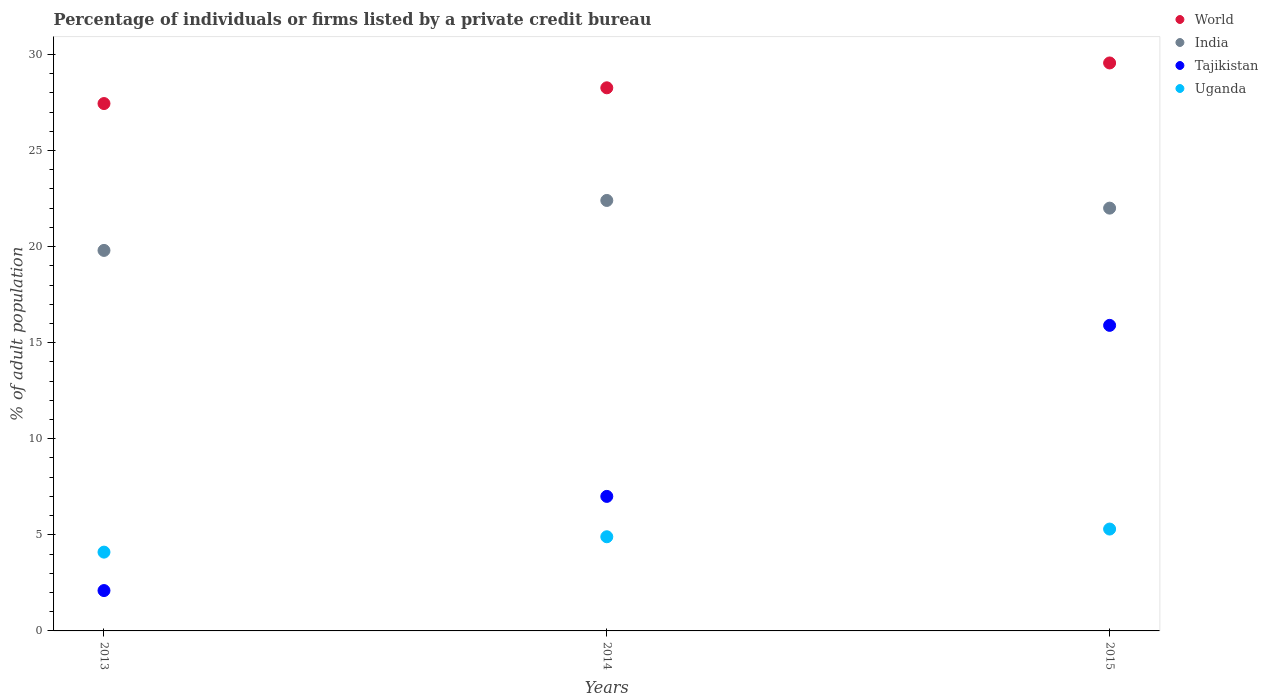Is the number of dotlines equal to the number of legend labels?
Provide a short and direct response. Yes. What is the percentage of population listed by a private credit bureau in World in 2013?
Provide a short and direct response. 27.44. Across all years, what is the minimum percentage of population listed by a private credit bureau in World?
Give a very brief answer. 27.44. In which year was the percentage of population listed by a private credit bureau in Uganda maximum?
Offer a very short reply. 2015. What is the total percentage of population listed by a private credit bureau in India in the graph?
Ensure brevity in your answer.  64.2. What is the difference between the percentage of population listed by a private credit bureau in World in 2013 and that in 2015?
Provide a succinct answer. -2.11. What is the average percentage of population listed by a private credit bureau in World per year?
Make the answer very short. 28.42. In the year 2013, what is the difference between the percentage of population listed by a private credit bureau in India and percentage of population listed by a private credit bureau in Uganda?
Ensure brevity in your answer.  15.7. In how many years, is the percentage of population listed by a private credit bureau in World greater than 7 %?
Give a very brief answer. 3. Is the percentage of population listed by a private credit bureau in Tajikistan in 2014 less than that in 2015?
Ensure brevity in your answer.  Yes. What is the difference between the highest and the second highest percentage of population listed by a private credit bureau in India?
Your answer should be compact. 0.4. What is the difference between the highest and the lowest percentage of population listed by a private credit bureau in Uganda?
Give a very brief answer. 1.2. Is it the case that in every year, the sum of the percentage of population listed by a private credit bureau in India and percentage of population listed by a private credit bureau in Tajikistan  is greater than the percentage of population listed by a private credit bureau in Uganda?
Give a very brief answer. Yes. What is the difference between two consecutive major ticks on the Y-axis?
Your answer should be very brief. 5. Does the graph contain any zero values?
Ensure brevity in your answer.  No. How are the legend labels stacked?
Ensure brevity in your answer.  Vertical. What is the title of the graph?
Offer a very short reply. Percentage of individuals or firms listed by a private credit bureau. Does "Portugal" appear as one of the legend labels in the graph?
Ensure brevity in your answer.  No. What is the label or title of the X-axis?
Make the answer very short. Years. What is the label or title of the Y-axis?
Give a very brief answer. % of adult population. What is the % of adult population in World in 2013?
Your answer should be compact. 27.44. What is the % of adult population of India in 2013?
Your answer should be very brief. 19.8. What is the % of adult population in Tajikistan in 2013?
Keep it short and to the point. 2.1. What is the % of adult population in Uganda in 2013?
Offer a terse response. 4.1. What is the % of adult population of World in 2014?
Offer a very short reply. 28.26. What is the % of adult population in India in 2014?
Ensure brevity in your answer.  22.4. What is the % of adult population of Uganda in 2014?
Provide a short and direct response. 4.9. What is the % of adult population in World in 2015?
Provide a succinct answer. 29.55. What is the % of adult population of India in 2015?
Give a very brief answer. 22. What is the % of adult population in Tajikistan in 2015?
Give a very brief answer. 15.9. Across all years, what is the maximum % of adult population in World?
Give a very brief answer. 29.55. Across all years, what is the maximum % of adult population of India?
Offer a terse response. 22.4. Across all years, what is the minimum % of adult population of World?
Make the answer very short. 27.44. Across all years, what is the minimum % of adult population of India?
Give a very brief answer. 19.8. Across all years, what is the minimum % of adult population in Tajikistan?
Make the answer very short. 2.1. What is the total % of adult population in World in the graph?
Your answer should be very brief. 85.26. What is the total % of adult population of India in the graph?
Provide a short and direct response. 64.2. What is the total % of adult population of Tajikistan in the graph?
Provide a short and direct response. 25. What is the difference between the % of adult population of World in 2013 and that in 2014?
Your answer should be very brief. -0.82. What is the difference between the % of adult population of Tajikistan in 2013 and that in 2014?
Provide a short and direct response. -4.9. What is the difference between the % of adult population in Uganda in 2013 and that in 2014?
Give a very brief answer. -0.8. What is the difference between the % of adult population of World in 2013 and that in 2015?
Offer a very short reply. -2.11. What is the difference between the % of adult population of Tajikistan in 2013 and that in 2015?
Provide a succinct answer. -13.8. What is the difference between the % of adult population in Uganda in 2013 and that in 2015?
Provide a short and direct response. -1.2. What is the difference between the % of adult population of World in 2014 and that in 2015?
Provide a short and direct response. -1.29. What is the difference between the % of adult population of Uganda in 2014 and that in 2015?
Your answer should be compact. -0.4. What is the difference between the % of adult population in World in 2013 and the % of adult population in India in 2014?
Your answer should be compact. 5.04. What is the difference between the % of adult population in World in 2013 and the % of adult population in Tajikistan in 2014?
Offer a terse response. 20.44. What is the difference between the % of adult population in World in 2013 and the % of adult population in Uganda in 2014?
Keep it short and to the point. 22.54. What is the difference between the % of adult population of India in 2013 and the % of adult population of Uganda in 2014?
Your response must be concise. 14.9. What is the difference between the % of adult population in Tajikistan in 2013 and the % of adult population in Uganda in 2014?
Your answer should be compact. -2.8. What is the difference between the % of adult population of World in 2013 and the % of adult population of India in 2015?
Make the answer very short. 5.44. What is the difference between the % of adult population in World in 2013 and the % of adult population in Tajikistan in 2015?
Your response must be concise. 11.54. What is the difference between the % of adult population in World in 2013 and the % of adult population in Uganda in 2015?
Your answer should be compact. 22.14. What is the difference between the % of adult population of India in 2013 and the % of adult population of Uganda in 2015?
Your response must be concise. 14.5. What is the difference between the % of adult population of World in 2014 and the % of adult population of India in 2015?
Your answer should be very brief. 6.26. What is the difference between the % of adult population in World in 2014 and the % of adult population in Tajikistan in 2015?
Offer a very short reply. 12.36. What is the difference between the % of adult population in World in 2014 and the % of adult population in Uganda in 2015?
Ensure brevity in your answer.  22.96. What is the difference between the % of adult population in India in 2014 and the % of adult population in Uganda in 2015?
Make the answer very short. 17.1. What is the difference between the % of adult population in Tajikistan in 2014 and the % of adult population in Uganda in 2015?
Your response must be concise. 1.7. What is the average % of adult population of World per year?
Provide a succinct answer. 28.42. What is the average % of adult population in India per year?
Offer a terse response. 21.4. What is the average % of adult population in Tajikistan per year?
Your response must be concise. 8.33. What is the average % of adult population in Uganda per year?
Offer a very short reply. 4.77. In the year 2013, what is the difference between the % of adult population in World and % of adult population in India?
Offer a terse response. 7.64. In the year 2013, what is the difference between the % of adult population of World and % of adult population of Tajikistan?
Keep it short and to the point. 25.34. In the year 2013, what is the difference between the % of adult population in World and % of adult population in Uganda?
Keep it short and to the point. 23.34. In the year 2013, what is the difference between the % of adult population of India and % of adult population of Uganda?
Provide a short and direct response. 15.7. In the year 2013, what is the difference between the % of adult population of Tajikistan and % of adult population of Uganda?
Make the answer very short. -2. In the year 2014, what is the difference between the % of adult population in World and % of adult population in India?
Provide a short and direct response. 5.86. In the year 2014, what is the difference between the % of adult population of World and % of adult population of Tajikistan?
Provide a succinct answer. 21.26. In the year 2014, what is the difference between the % of adult population in World and % of adult population in Uganda?
Your answer should be very brief. 23.36. In the year 2014, what is the difference between the % of adult population in India and % of adult population in Tajikistan?
Your response must be concise. 15.4. In the year 2015, what is the difference between the % of adult population in World and % of adult population in India?
Give a very brief answer. 7.55. In the year 2015, what is the difference between the % of adult population in World and % of adult population in Tajikistan?
Keep it short and to the point. 13.65. In the year 2015, what is the difference between the % of adult population of World and % of adult population of Uganda?
Offer a terse response. 24.25. In the year 2015, what is the difference between the % of adult population in India and % of adult population in Tajikistan?
Keep it short and to the point. 6.1. In the year 2015, what is the difference between the % of adult population of India and % of adult population of Uganda?
Provide a succinct answer. 16.7. In the year 2015, what is the difference between the % of adult population of Tajikistan and % of adult population of Uganda?
Keep it short and to the point. 10.6. What is the ratio of the % of adult population in India in 2013 to that in 2014?
Your response must be concise. 0.88. What is the ratio of the % of adult population of Tajikistan in 2013 to that in 2014?
Your answer should be compact. 0.3. What is the ratio of the % of adult population of Uganda in 2013 to that in 2014?
Offer a terse response. 0.84. What is the ratio of the % of adult population of World in 2013 to that in 2015?
Give a very brief answer. 0.93. What is the ratio of the % of adult population in Tajikistan in 2013 to that in 2015?
Give a very brief answer. 0.13. What is the ratio of the % of adult population of Uganda in 2013 to that in 2015?
Offer a terse response. 0.77. What is the ratio of the % of adult population in World in 2014 to that in 2015?
Provide a short and direct response. 0.96. What is the ratio of the % of adult population of India in 2014 to that in 2015?
Offer a terse response. 1.02. What is the ratio of the % of adult population in Tajikistan in 2014 to that in 2015?
Provide a short and direct response. 0.44. What is the ratio of the % of adult population in Uganda in 2014 to that in 2015?
Your response must be concise. 0.92. What is the difference between the highest and the second highest % of adult population of World?
Keep it short and to the point. 1.29. What is the difference between the highest and the second highest % of adult population in India?
Give a very brief answer. 0.4. What is the difference between the highest and the lowest % of adult population in World?
Keep it short and to the point. 2.11. 